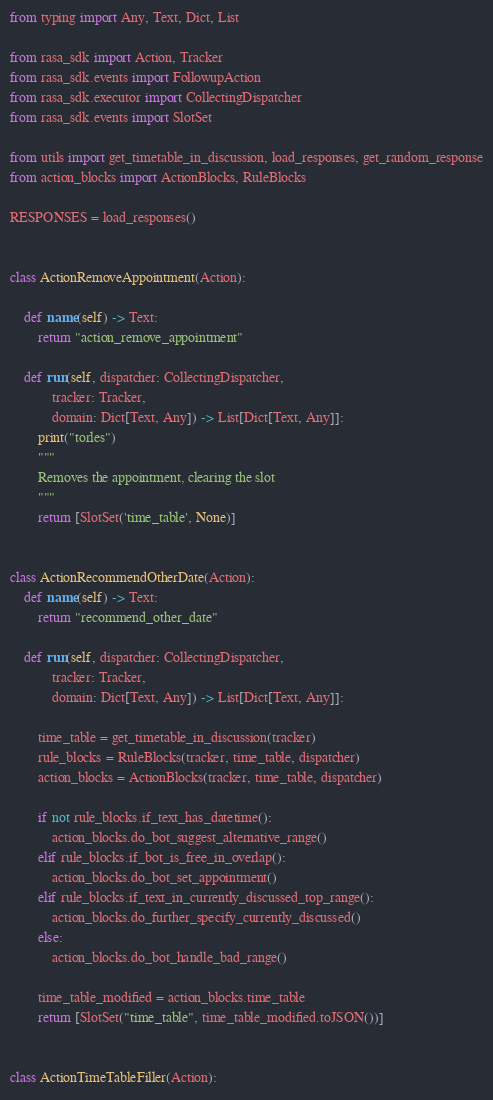<code> <loc_0><loc_0><loc_500><loc_500><_Python_>from typing import Any, Text, Dict, List

from rasa_sdk import Action, Tracker
from rasa_sdk.events import FollowupAction
from rasa_sdk.executor import CollectingDispatcher
from rasa_sdk.events import SlotSet

from utils import get_timetable_in_discussion, load_responses, get_random_response
from action_blocks import ActionBlocks, RuleBlocks

RESPONSES = load_responses()


class ActionRemoveAppointment(Action):

    def name(self) -> Text:
        return "action_remove_appointment"

    def run(self, dispatcher: CollectingDispatcher,
            tracker: Tracker,
            domain: Dict[Text, Any]) -> List[Dict[Text, Any]]:
        print("torles")
        """
        Removes the appointment, clearing the slot
        """
        return [SlotSet('time_table', None)]


class ActionRecommendOtherDate(Action):
    def name(self) -> Text:
        return "recommend_other_date"

    def run(self, dispatcher: CollectingDispatcher,
            tracker: Tracker,
            domain: Dict[Text, Any]) -> List[Dict[Text, Any]]:

        time_table = get_timetable_in_discussion(tracker)
        rule_blocks = RuleBlocks(tracker, time_table, dispatcher)
        action_blocks = ActionBlocks(tracker, time_table, dispatcher)

        if not rule_blocks.if_text_has_datetime():
            action_blocks.do_bot_suggest_alternative_range()
        elif rule_blocks.if_bot_is_free_in_overlap():
            action_blocks.do_bot_set_appointment()
        elif rule_blocks.if_text_in_currently_discussed_top_range():
            action_blocks.do_further_specify_currently_discussed()
        else:
            action_blocks.do_bot_handle_bad_range()

        time_table_modified = action_blocks.time_table
        return [SlotSet("time_table", time_table_modified.toJSON())]


class ActionTimeTableFiller(Action):
</code> 